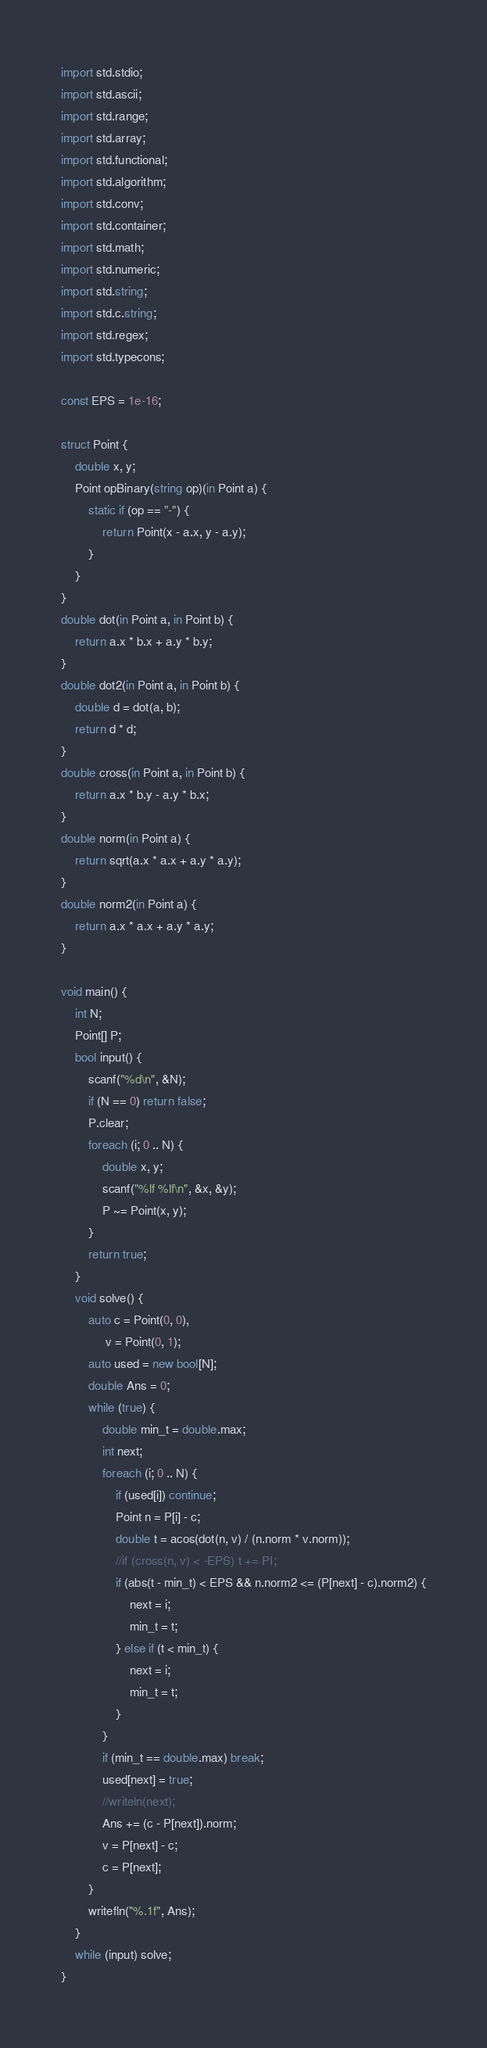<code> <loc_0><loc_0><loc_500><loc_500><_D_>import std.stdio;
import std.ascii;
import std.range;
import std.array;
import std.functional;
import std.algorithm;
import std.conv;
import std.container;
import std.math;
import std.numeric;
import std.string;
import std.c.string;
import std.regex;
import std.typecons;

const EPS = 1e-16;

struct Point {
    double x, y;
    Point opBinary(string op)(in Point a) {
        static if (op == "-") {
            return Point(x - a.x, y - a.y);
        }
    }
}
double dot(in Point a, in Point b) {
    return a.x * b.x + a.y * b.y;
}
double dot2(in Point a, in Point b) {
    double d = dot(a, b);
    return d * d;
}
double cross(in Point a, in Point b) {
    return a.x * b.y - a.y * b.x;
}
double norm(in Point a) {
    return sqrt(a.x * a.x + a.y * a.y);
}
double norm2(in Point a) {
    return a.x * a.x + a.y * a.y;
}

void main() {
    int N;
    Point[] P;
    bool input() {
        scanf("%d\n", &N);
        if (N == 0) return false;
        P.clear;
        foreach (i; 0 .. N) {
            double x, y;
            scanf("%lf %lf\n", &x, &y);
            P ~= Point(x, y);
        }
        return true;
    }
    void solve() {
        auto c = Point(0, 0),
             v = Point(0, 1);
        auto used = new bool[N];
        double Ans = 0;
        while (true) {
            double min_t = double.max;
            int next;
            foreach (i; 0 .. N) {
                if (used[i]) continue;
                Point n = P[i] - c;
                double t = acos(dot(n, v) / (n.norm * v.norm));
                //if (cross(n, v) < -EPS) t += PI;
                if (abs(t - min_t) < EPS && n.norm2 <= (P[next] - c).norm2) {
                    next = i;
                    min_t = t;
                } else if (t < min_t) {
                    next = i;
                    min_t = t;
                }
            }
            if (min_t == double.max) break;
            used[next] = true;
            //writeln(next);
            Ans += (c - P[next]).norm;
            v = P[next] - c;
            c = P[next];
        }
        writefln("%.1f", Ans);
    }
    while (input) solve;
}</code> 